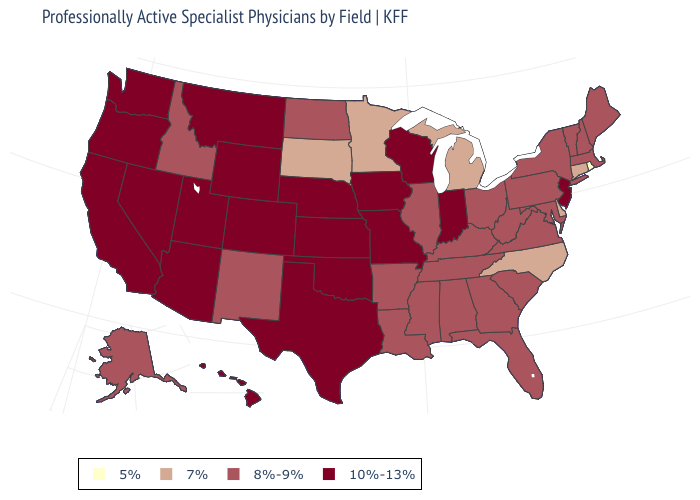Does Missouri have the highest value in the USA?
Give a very brief answer. Yes. Which states have the highest value in the USA?
Give a very brief answer. Arizona, California, Colorado, Hawaii, Indiana, Iowa, Kansas, Missouri, Montana, Nebraska, Nevada, New Jersey, Oklahoma, Oregon, Texas, Utah, Washington, Wisconsin, Wyoming. Name the states that have a value in the range 8%-9%?
Quick response, please. Alabama, Alaska, Arkansas, Florida, Georgia, Idaho, Illinois, Kentucky, Louisiana, Maine, Maryland, Massachusetts, Mississippi, New Hampshire, New Mexico, New York, North Dakota, Ohio, Pennsylvania, South Carolina, Tennessee, Vermont, Virginia, West Virginia. What is the value of North Dakota?
Write a very short answer. 8%-9%. What is the value of Rhode Island?
Concise answer only. 5%. What is the value of Kentucky?
Keep it brief. 8%-9%. What is the lowest value in states that border Michigan?
Write a very short answer. 8%-9%. Name the states that have a value in the range 10%-13%?
Write a very short answer. Arizona, California, Colorado, Hawaii, Indiana, Iowa, Kansas, Missouri, Montana, Nebraska, Nevada, New Jersey, Oklahoma, Oregon, Texas, Utah, Washington, Wisconsin, Wyoming. Does the first symbol in the legend represent the smallest category?
Be succinct. Yes. Among the states that border Ohio , which have the lowest value?
Concise answer only. Michigan. Does Arizona have the highest value in the West?
Keep it brief. Yes. Which states have the highest value in the USA?
Answer briefly. Arizona, California, Colorado, Hawaii, Indiana, Iowa, Kansas, Missouri, Montana, Nebraska, Nevada, New Jersey, Oklahoma, Oregon, Texas, Utah, Washington, Wisconsin, Wyoming. What is the value of Ohio?
Concise answer only. 8%-9%. Name the states that have a value in the range 7%?
Keep it brief. Connecticut, Delaware, Michigan, Minnesota, North Carolina, South Dakota. 